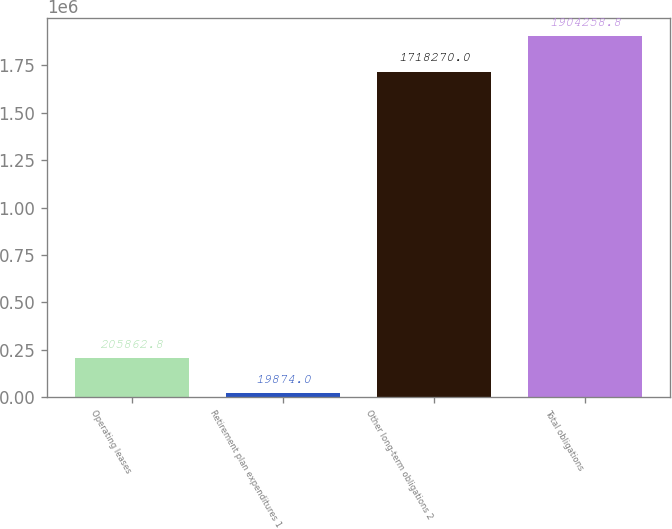Convert chart. <chart><loc_0><loc_0><loc_500><loc_500><bar_chart><fcel>Operating leases<fcel>Retirement plan expenditures 1<fcel>Other long-term obligations 2<fcel>Total obligations<nl><fcel>205863<fcel>19874<fcel>1.71827e+06<fcel>1.90426e+06<nl></chart> 